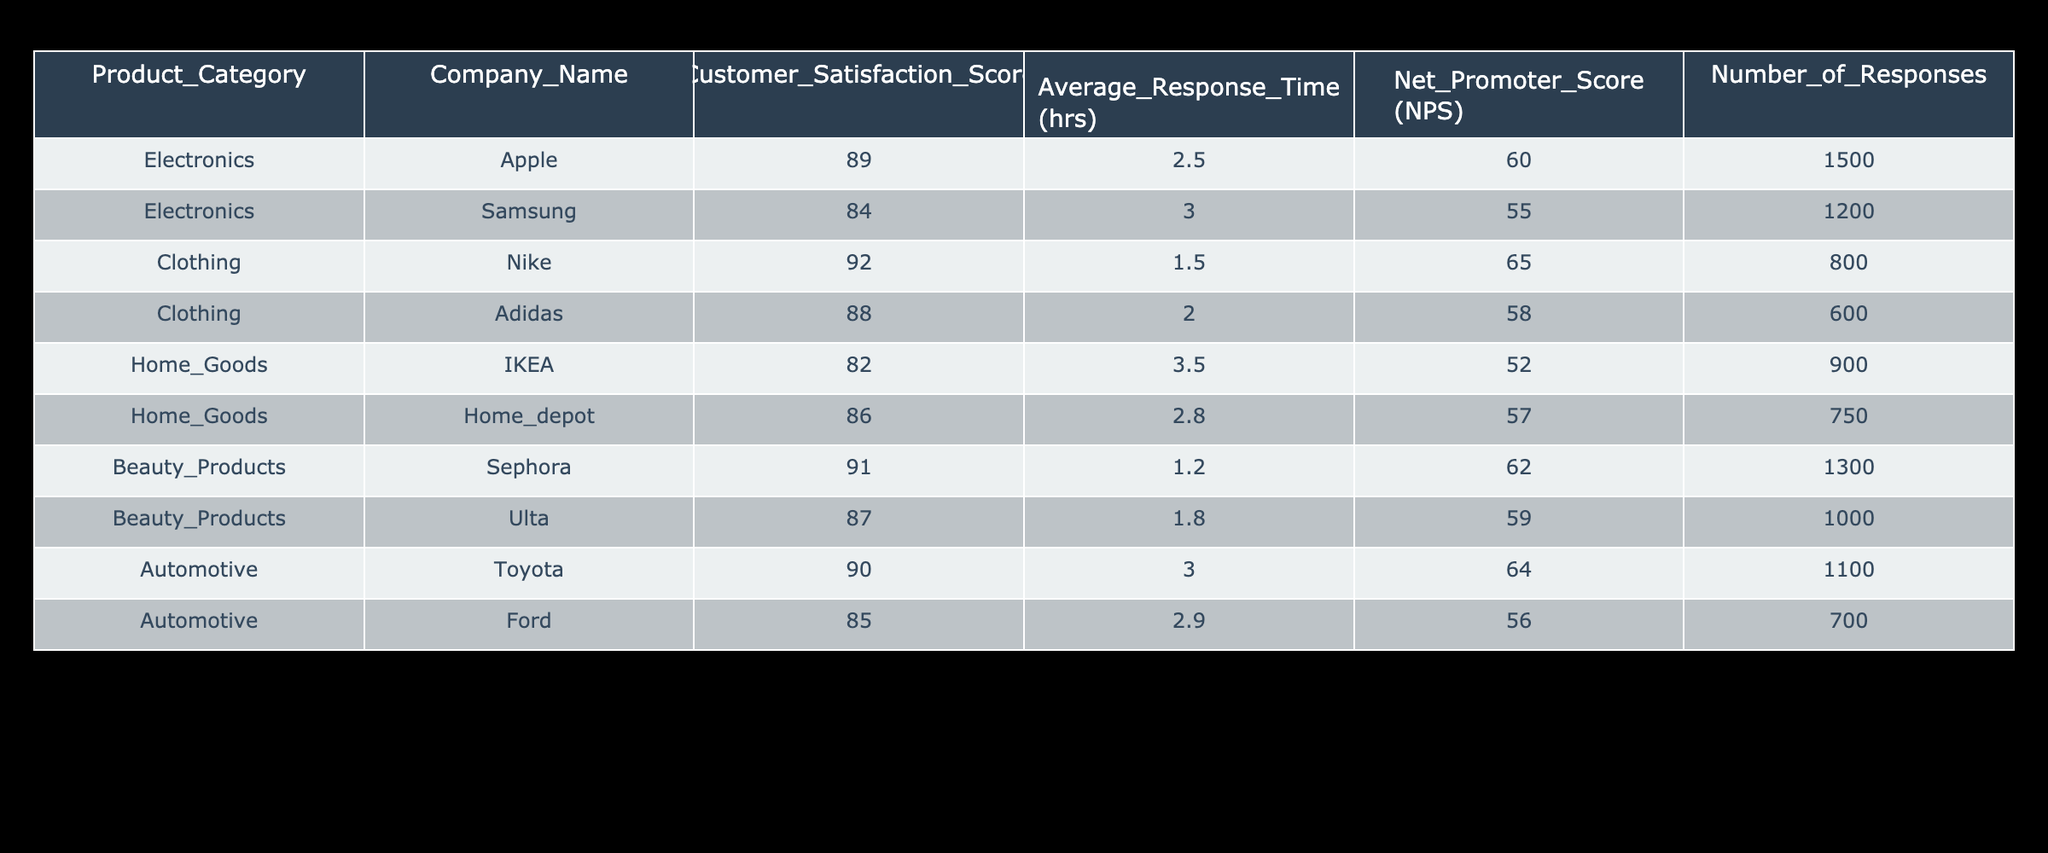What is the Customer Satisfaction Score for Nike? According to the table, the Customer Satisfaction Score for Nike under the Clothing category is listed as 92.
Answer: 92 Which company has the highest Net Promoter Score (NPS)? Looking at the table, Nike has the highest NPS of 65 among the listed companies.
Answer: Nike What is the average Customer Satisfaction Score for Home Goods products? To find the average, we take the scores of IKEA (82) and Home Depot (86), sum them up (82 + 86 = 168) and divide by 2. Thus, the average score is 168 / 2 = 84.
Answer: 84 Is Sephora's Customer Satisfaction Score higher than Ulta's? Yes, Sephora has a Customer Satisfaction Score of 91 while Ulta's score is 87, making Sephora's score higher.
Answer: Yes What is the difference in Customer Satisfaction Scores between Toyota and Ford? The Customer Satisfaction Score for Toyota is 90 and for Ford it is 85. The difference is calculated as 90 - 85 = 5.
Answer: 5 Which product category has the lowest average Customer Satisfaction Score? To determine this, we compute the average for each category: Electronics (86.5), Clothing (90), Home Goods (84), Beauty Products (89), and Automotive (87.5). Home Goods has the lowest average of 84.
Answer: Home Goods Does any company have a Customer Satisfaction Score above 90? Yes, Nike (92), Sephora (91), and Apple (89) all have scores above 90.
Answer: Yes What is the total number of responses for the Automotive category? The total number of responses for the Automotive category includes Toyota (1100) and Ford (700). Therefore, we add these values to get 1100 + 700 = 1800.
Answer: 1800 What is the average response time for Electronics products? We find the average response time by adding Apple's response time (2.5) and Samsung's (3.0), which totals 5.5 hours. Dividing by the number of companies in this category (2) gives us an average response time of 5.5 / 2 = 2.75 hours.
Answer: 2.75 